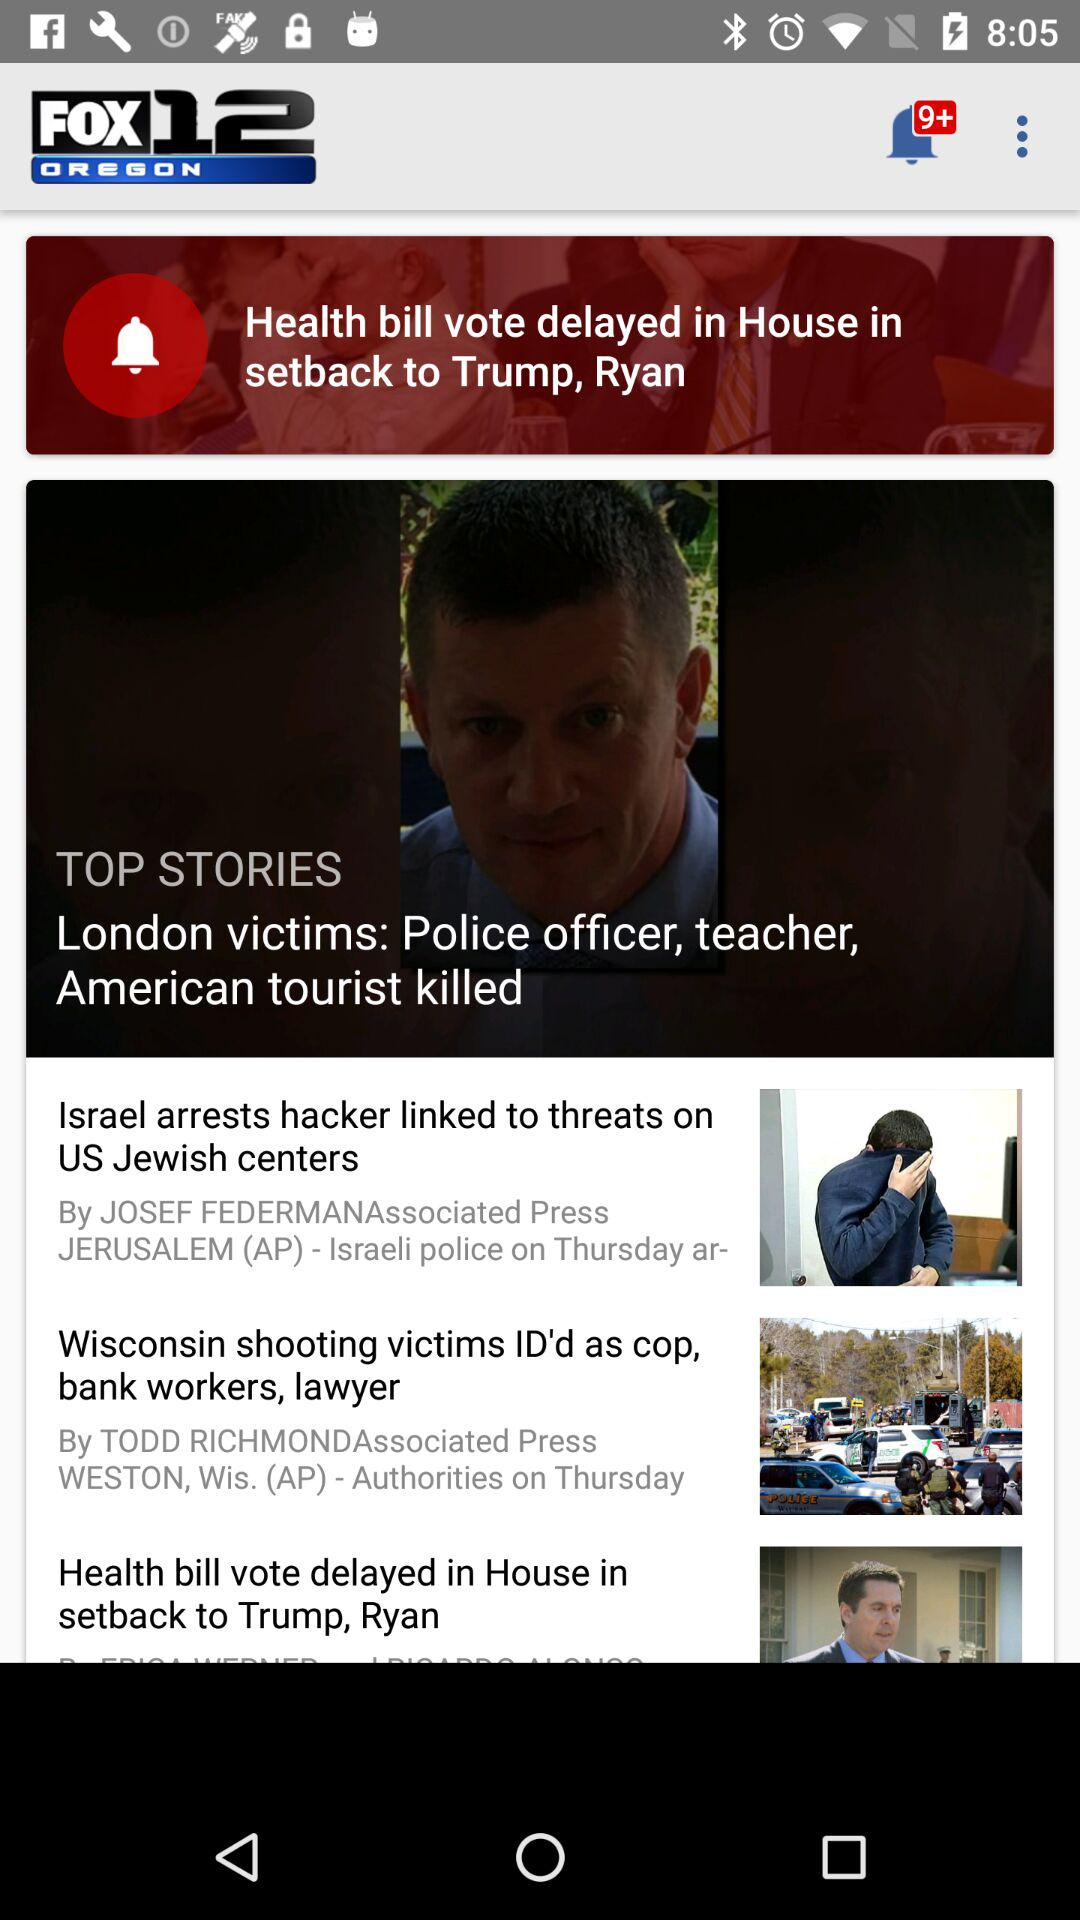What is the name of the news channel? The name of the news channel is "FOX12 OREGON". 